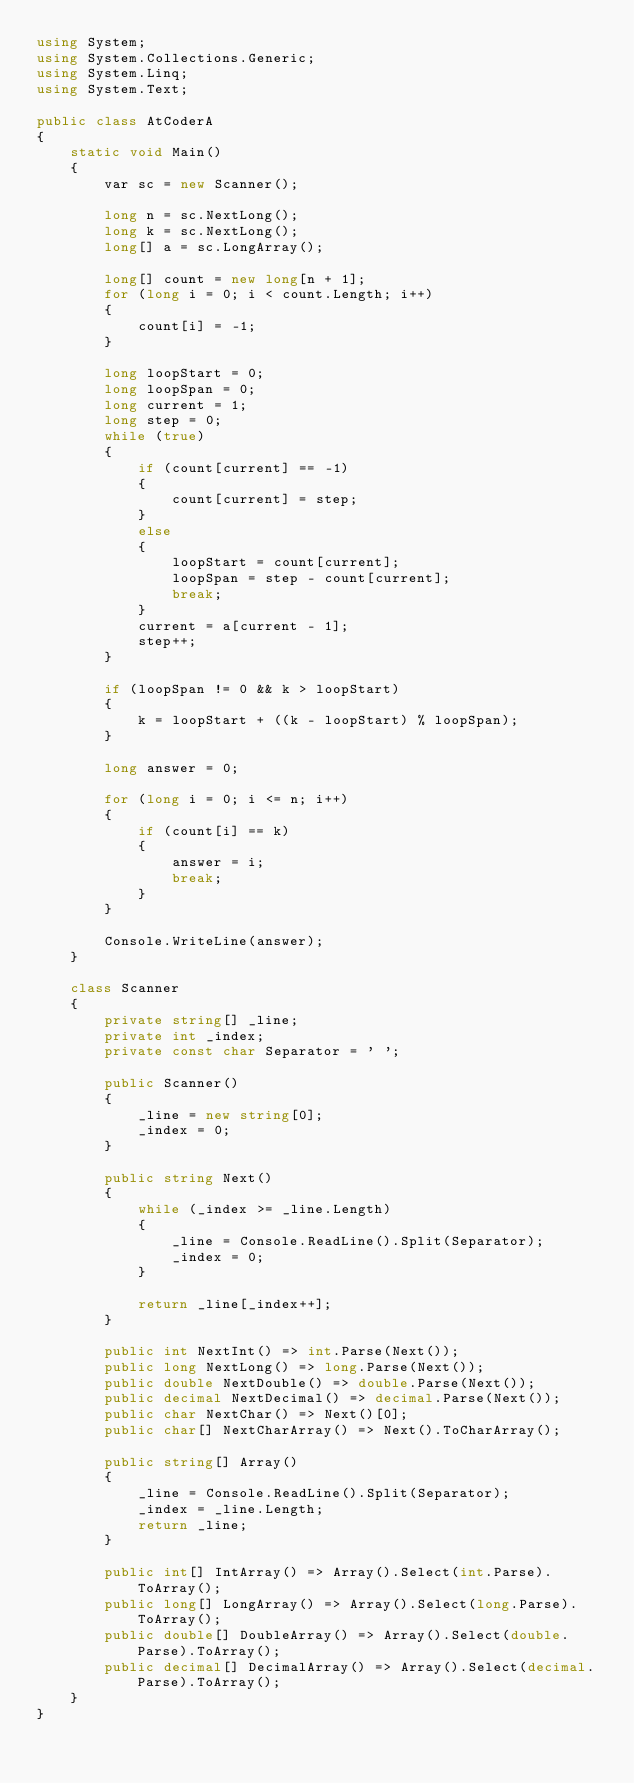<code> <loc_0><loc_0><loc_500><loc_500><_C#_>using System;
using System.Collections.Generic;
using System.Linq;
using System.Text;

public class AtCoderA
{
    static void Main()
    {
        var sc = new Scanner();

        long n = sc.NextLong();
        long k = sc.NextLong();
        long[] a = sc.LongArray();

        long[] count = new long[n + 1];
        for (long i = 0; i < count.Length; i++)
        {
            count[i] = -1;
        }

        long loopStart = 0;
        long loopSpan = 0;
        long current = 1;
        long step = 0;
        while (true)
        {
            if (count[current] == -1)
            {
                count[current] = step;
            }
            else
            {
                loopStart = count[current];
                loopSpan = step - count[current];
                break;
            }
            current = a[current - 1];
            step++;
        }

        if (loopSpan != 0 && k > loopStart)
        {
            k = loopStart + ((k - loopStart) % loopSpan);
        }

        long answer = 0;

        for (long i = 0; i <= n; i++)
        {
            if (count[i] == k)
            {
                answer = i;
                break;
            }
        }

        Console.WriteLine(answer);
    }

    class Scanner
    {
        private string[] _line;
        private int _index;
        private const char Separator = ' ';

        public Scanner()
        {
            _line = new string[0];
            _index = 0;
        }

        public string Next()
        {
            while (_index >= _line.Length)
            {
                _line = Console.ReadLine().Split(Separator);
                _index = 0;
            }

            return _line[_index++];
        }

        public int NextInt() => int.Parse(Next());
        public long NextLong() => long.Parse(Next());
        public double NextDouble() => double.Parse(Next());
        public decimal NextDecimal() => decimal.Parse(Next());
        public char NextChar() => Next()[0];
        public char[] NextCharArray() => Next().ToCharArray();

        public string[] Array()
        {
            _line = Console.ReadLine().Split(Separator);
            _index = _line.Length;
            return _line;
        }

        public int[] IntArray() => Array().Select(int.Parse).ToArray();
        public long[] LongArray() => Array().Select(long.Parse).ToArray();
        public double[] DoubleArray() => Array().Select(double.Parse).ToArray();
        public decimal[] DecimalArray() => Array().Select(decimal.Parse).ToArray();
    }
}</code> 